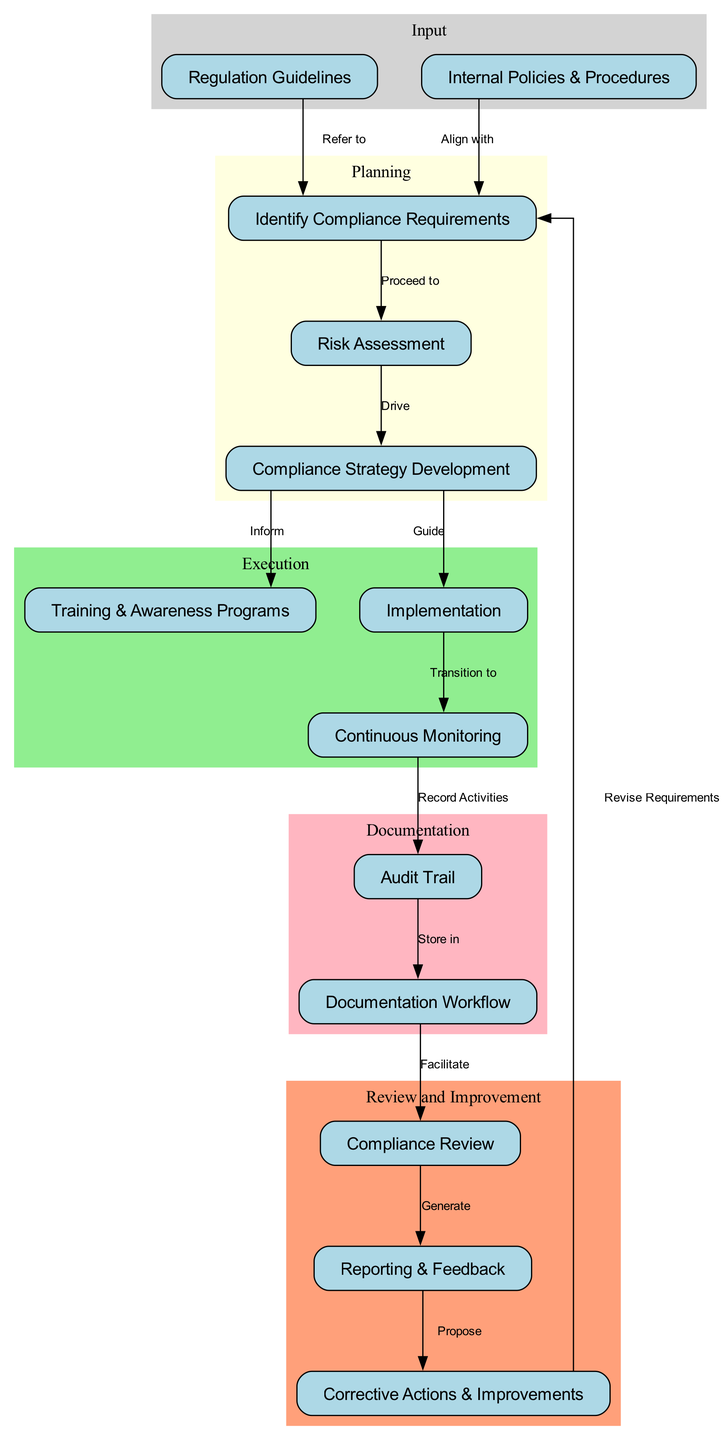What is the first step in the compliance monitoring process? The first step is represented by the node labeled "Regulation Guidelines," which indicates the initial reference point in the process.
Answer: Regulation Guidelines How many nodes are there in total? By counting the labeled nodes in the diagram, there are a total of 13 distinct nodes.
Answer: 13 What does the "Risk Assessment" node drive? The "Risk Assessment" node drives the "Compliance Strategy Development" as indicated by the directed edge with the label "Drive."
Answer: Compliance Strategy Development Which two nodes align with "Identify Compliance Requirements"? The "Regulation Guidelines" and "Internal Policies & Procedures" nodes align with "Identify Compliance Requirements," as both have edges directed towards this node indicating their alignment with the compliance identification process.
Answer: Regulation Guidelines, Internal Policies & Procedures What is stored in the "Documentation Workflow"? The "Documentation Workflow" node stores the output from the "Audit Trail" node as indicated by the directed edge with the label "Store in."
Answer: Audit Trail What action is proposed in the "Reporting" node? The "Reporting" node proposes "Corrective Actions & Improvements" as indicated by the directed edge with the label "Propose."
Answer: Corrective Actions & Improvements What color represents the "Execution" cluster in the diagram? The color that represents the "Execution" cluster in the diagram is light green, as specified in the graph attributes for that subgraph.
Answer: Light green How is the "Monitoring" node related to the "Implementation" node? The "Monitoring" node transitions from the "Implementation" node, as indicated by the directed edge with the label "Transition to."
Answer: Transition to What are the three phases of the compliance monitoring process represented in the clusters? The three phases are "Input," "Planning," and "Execution," as labeled in the cluster sections of the diagram.
Answer: Input, Planning, Execution 